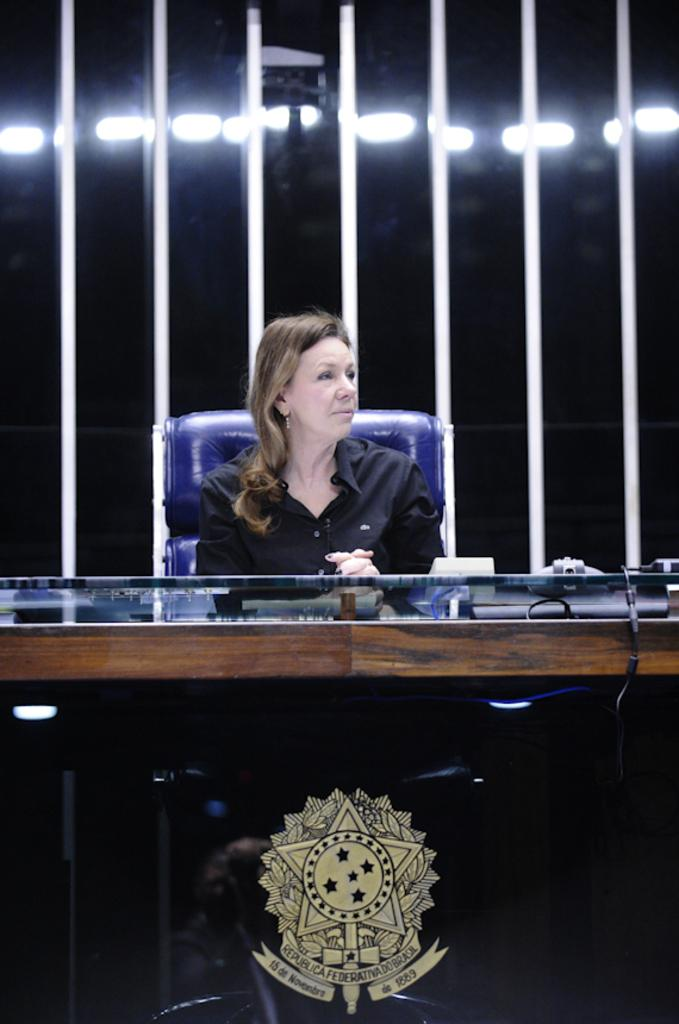Who is the main subject in the image? There is a woman in the image. What is the woman doing in the image? The woman is sitting on a chair. What other furniture or objects can be seen in the image? There is a table in the image. What can be seen in the background of the image? There are lights visible in the background of the image. What type of brain surgery is the woman performing on the stage in the image? There is no brain surgery or stage present in the image; it features a woman sitting on a chair with a table nearby and lights in the background. 